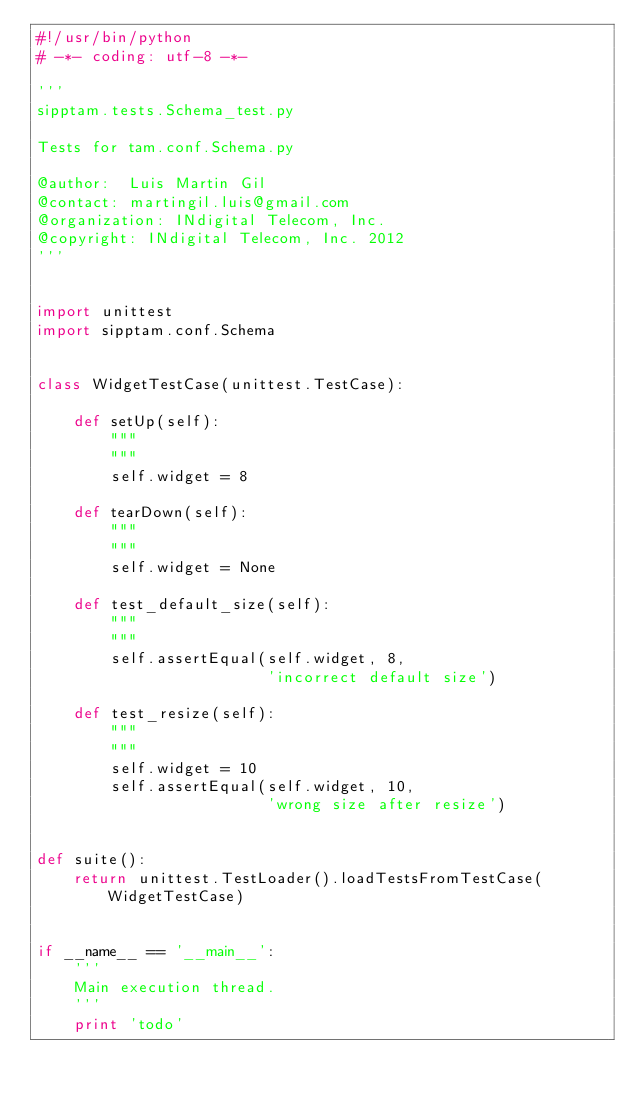Convert code to text. <code><loc_0><loc_0><loc_500><loc_500><_Python_>#!/usr/bin/python
# -*- coding: utf-8 -*-

'''
sipptam.tests.Schema_test.py

Tests for tam.conf.Schema.py

@author:  Luis Martin Gil
@contact: martingil.luis@gmail.com
@organization: INdigital Telecom, Inc.
@copyright: INdigital Telecom, Inc. 2012
'''


import unittest
import sipptam.conf.Schema


class WidgetTestCase(unittest.TestCase):

    def setUp(self):
        """
        """
        self.widget = 8

    def tearDown(self):
        """
        """
        self.widget = None

    def test_default_size(self):
        """
        """
        self.assertEqual(self.widget, 8,
                         'incorrect default size')

    def test_resize(self):
        """
        """
        self.widget = 10
        self.assertEqual(self.widget, 10,
                         'wrong size after resize')


def suite():
    return unittest.TestLoader().loadTestsFromTestCase(WidgetTestCase)


if __name__ == '__main__':
    '''
    Main execution thread.
    '''
    print 'todo'
</code> 